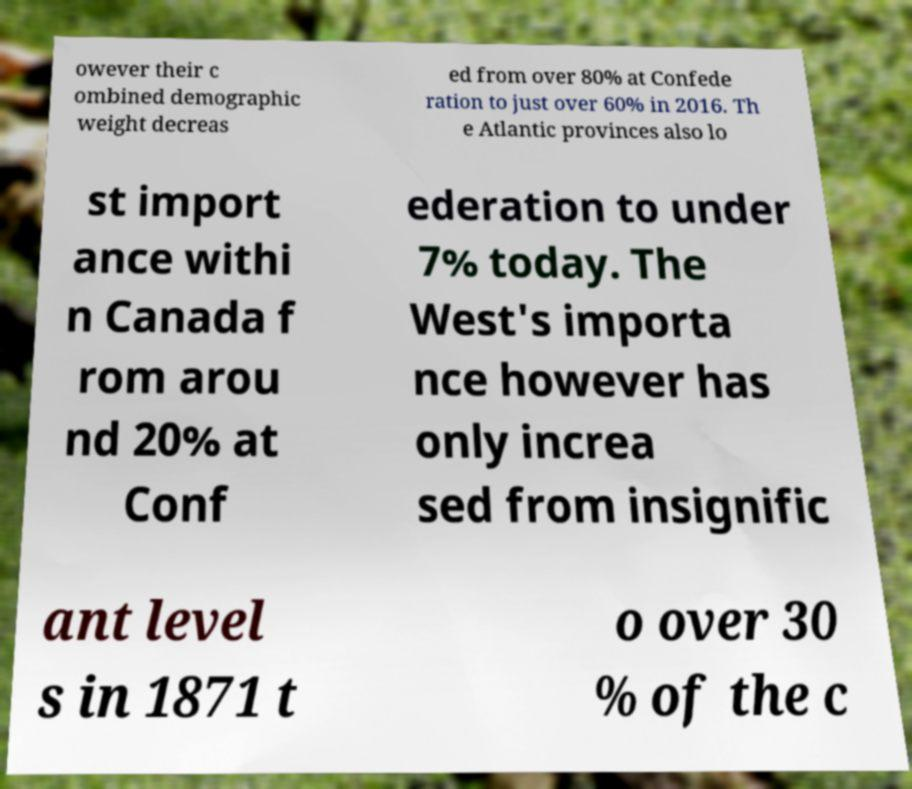Could you extract and type out the text from this image? owever their c ombined demographic weight decreas ed from over 80% at Confede ration to just over 60% in 2016. Th e Atlantic provinces also lo st import ance withi n Canada f rom arou nd 20% at Conf ederation to under 7% today. The West's importa nce however has only increa sed from insignific ant level s in 1871 t o over 30 % of the c 